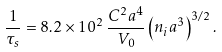<formula> <loc_0><loc_0><loc_500><loc_500>\frac { 1 } { \tau _ { s } } = 8 . 2 \times 1 0 ^ { 2 } \, \frac { C ^ { 2 } a ^ { 4 } } { V _ { 0 } } \left ( { n _ { i } a ^ { 3 } } \right ) ^ { 3 / 2 } .</formula> 